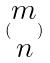<formula> <loc_0><loc_0><loc_500><loc_500>( \begin{matrix} m \\ n \end{matrix} )</formula> 